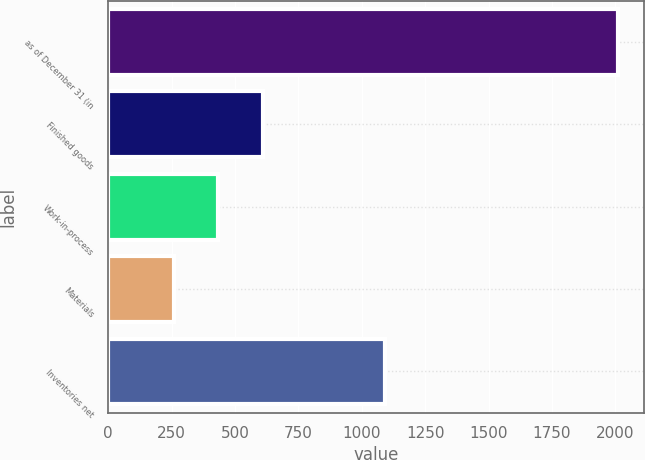<chart> <loc_0><loc_0><loc_500><loc_500><bar_chart><fcel>as of December 31 (in<fcel>Finished goods<fcel>Work-in-process<fcel>Materials<fcel>Inventories net<nl><fcel>2012<fcel>608.8<fcel>433.4<fcel>258<fcel>1091<nl></chart> 